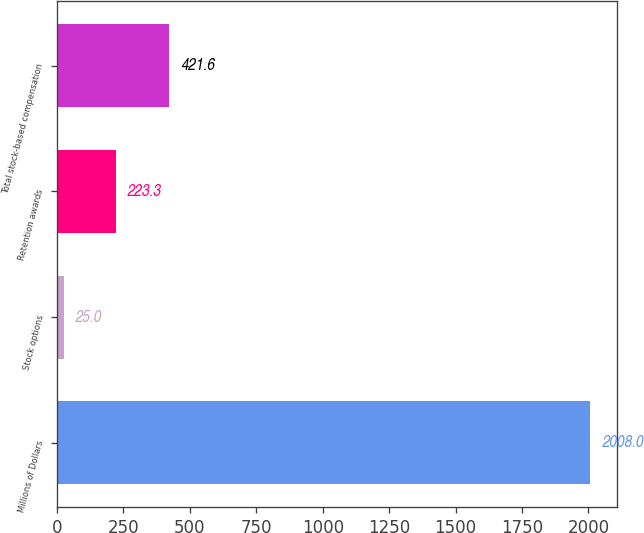Convert chart to OTSL. <chart><loc_0><loc_0><loc_500><loc_500><bar_chart><fcel>Millions of Dollars<fcel>Stock options<fcel>Retention awards<fcel>Total stock-based compensation<nl><fcel>2008<fcel>25<fcel>223.3<fcel>421.6<nl></chart> 